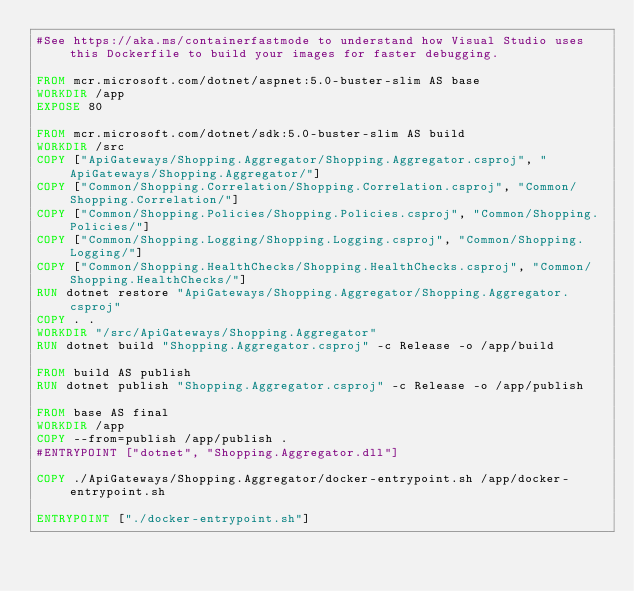Convert code to text. <code><loc_0><loc_0><loc_500><loc_500><_Dockerfile_>#See https://aka.ms/containerfastmode to understand how Visual Studio uses this Dockerfile to build your images for faster debugging.

FROM mcr.microsoft.com/dotnet/aspnet:5.0-buster-slim AS base
WORKDIR /app
EXPOSE 80

FROM mcr.microsoft.com/dotnet/sdk:5.0-buster-slim AS build
WORKDIR /src
COPY ["ApiGateways/Shopping.Aggregator/Shopping.Aggregator.csproj", "ApiGateways/Shopping.Aggregator/"]
COPY ["Common/Shopping.Correlation/Shopping.Correlation.csproj", "Common/Shopping.Correlation/"]
COPY ["Common/Shopping.Policies/Shopping.Policies.csproj", "Common/Shopping.Policies/"]
COPY ["Common/Shopping.Logging/Shopping.Logging.csproj", "Common/Shopping.Logging/"]
COPY ["Common/Shopping.HealthChecks/Shopping.HealthChecks.csproj", "Common/Shopping.HealthChecks/"]
RUN dotnet restore "ApiGateways/Shopping.Aggregator/Shopping.Aggregator.csproj"
COPY . .
WORKDIR "/src/ApiGateways/Shopping.Aggregator"
RUN dotnet build "Shopping.Aggregator.csproj" -c Release -o /app/build

FROM build AS publish
RUN dotnet publish "Shopping.Aggregator.csproj" -c Release -o /app/publish

FROM base AS final
WORKDIR /app
COPY --from=publish /app/publish .
#ENTRYPOINT ["dotnet", "Shopping.Aggregator.dll"]

COPY ./ApiGateways/Shopping.Aggregator/docker-entrypoint.sh /app/docker-entrypoint.sh

ENTRYPOINT ["./docker-entrypoint.sh"]</code> 